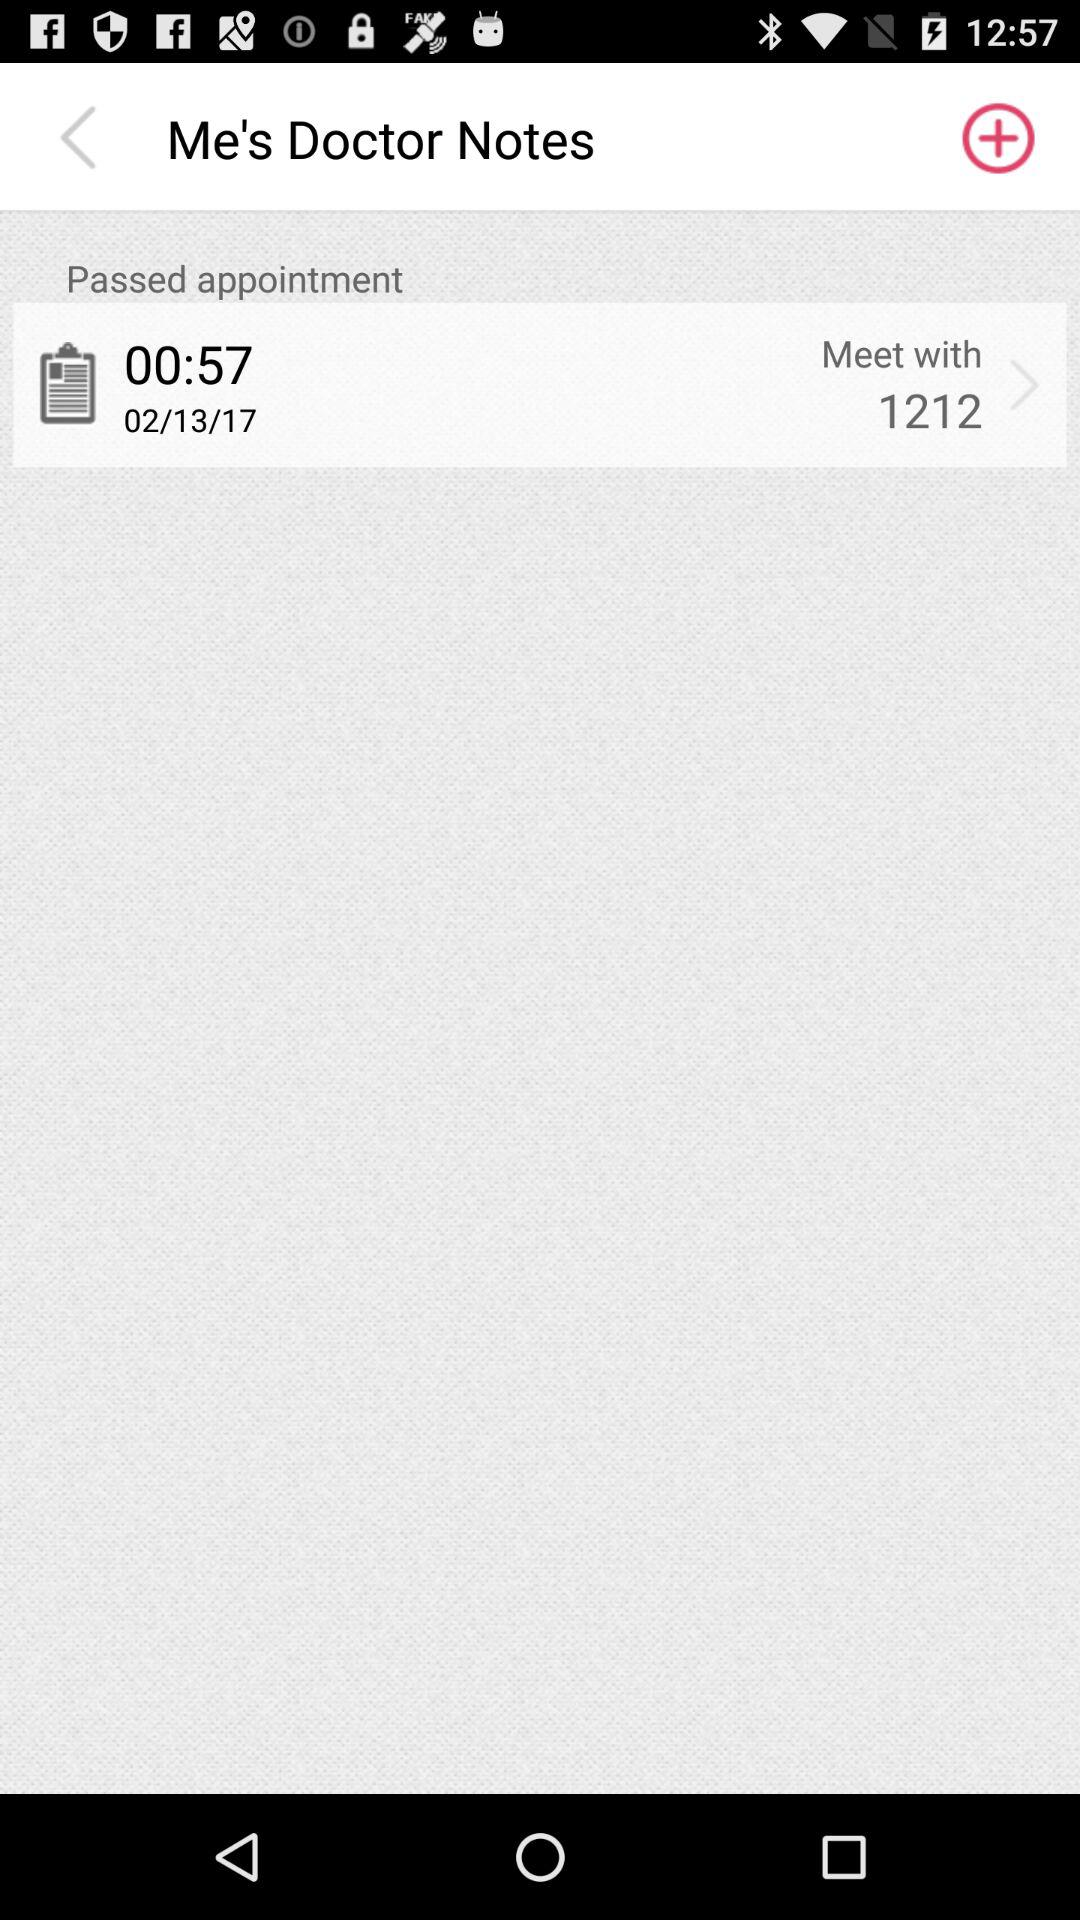What is the date of the appointment?
Answer the question using a single word or phrase. 02/13/17 